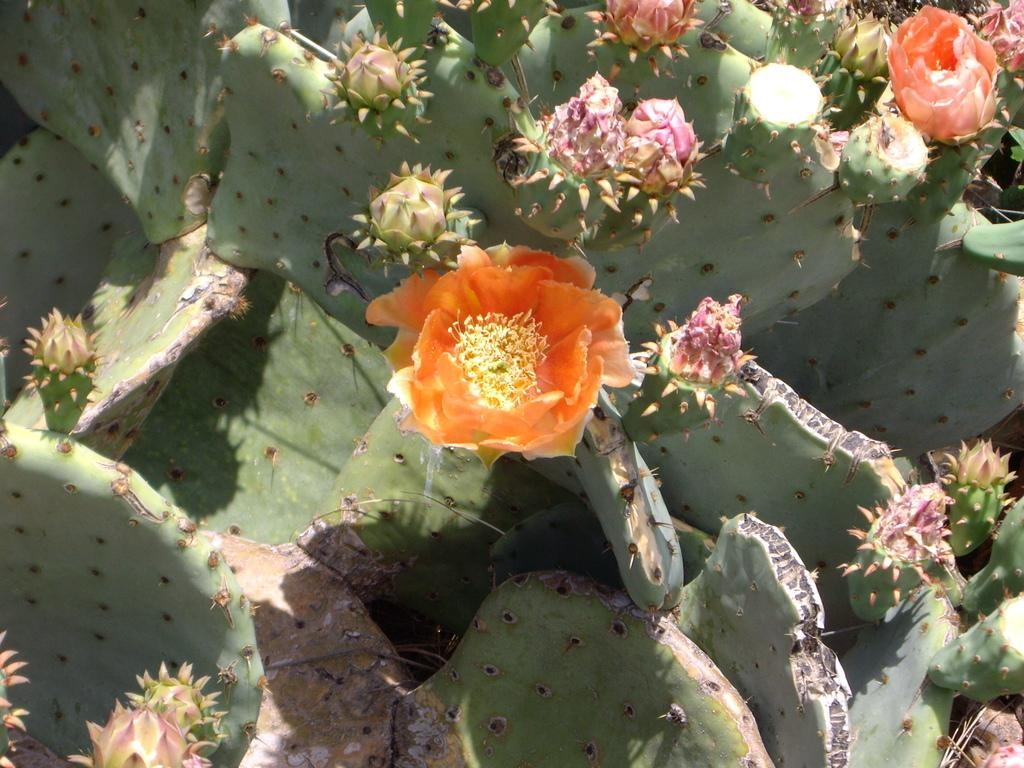What type of plants can be seen in the image? There are flowers and a cactus plant in the image. Can you describe the cactus plant in the image? The cactus plant is a type of succulent plant with thick, fleshy stems and spines. Where is the armchair located in the image? There is no armchair present in the image; it only features flowers and a cactus plant. 